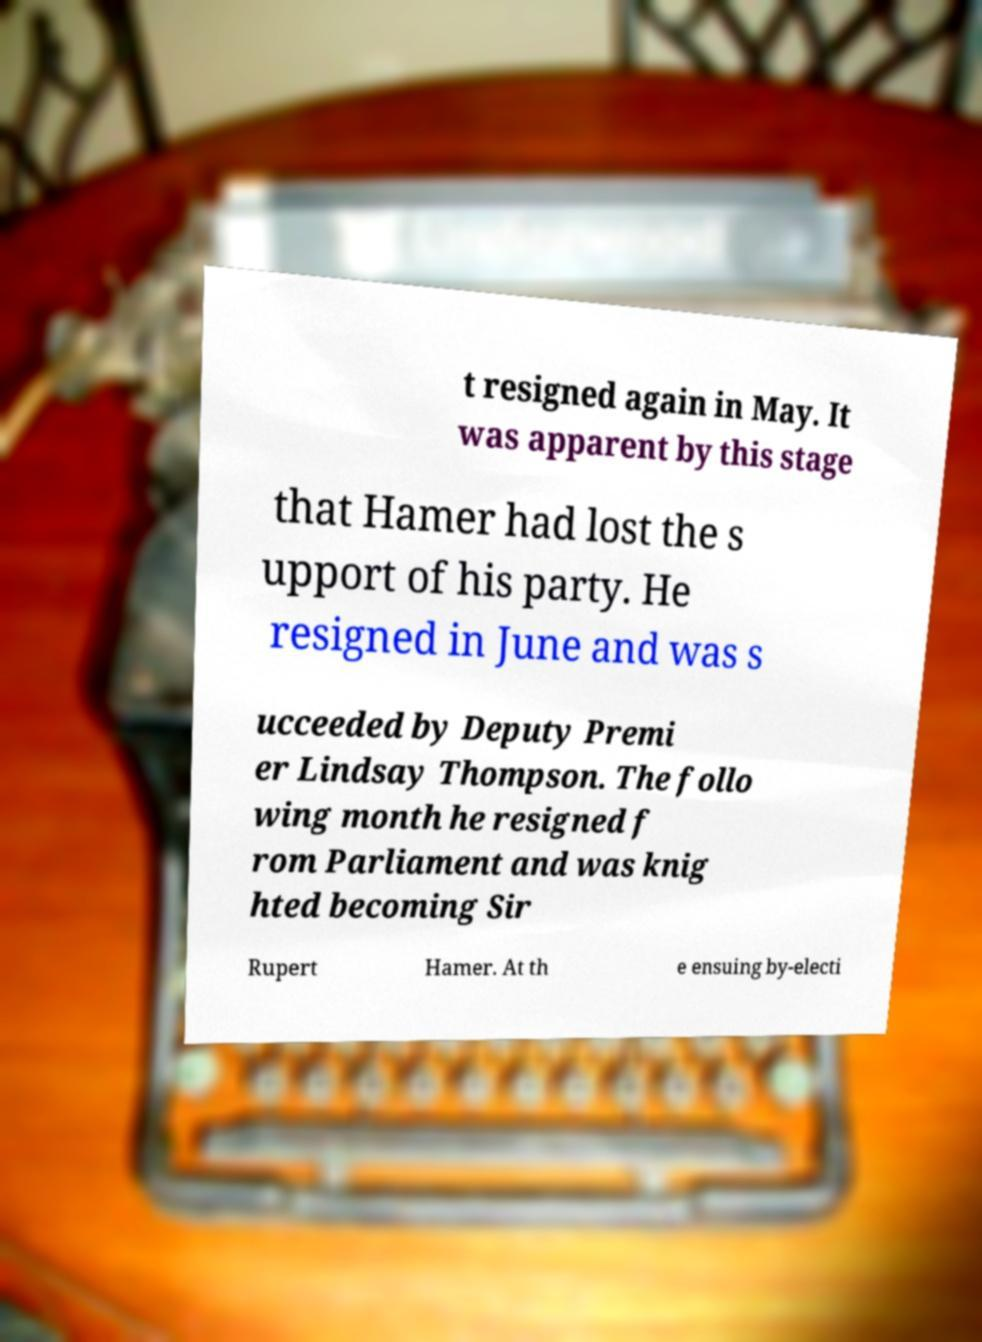I need the written content from this picture converted into text. Can you do that? t resigned again in May. It was apparent by this stage that Hamer had lost the s upport of his party. He resigned in June and was s ucceeded by Deputy Premi er Lindsay Thompson. The follo wing month he resigned f rom Parliament and was knig hted becoming Sir Rupert Hamer. At th e ensuing by-electi 